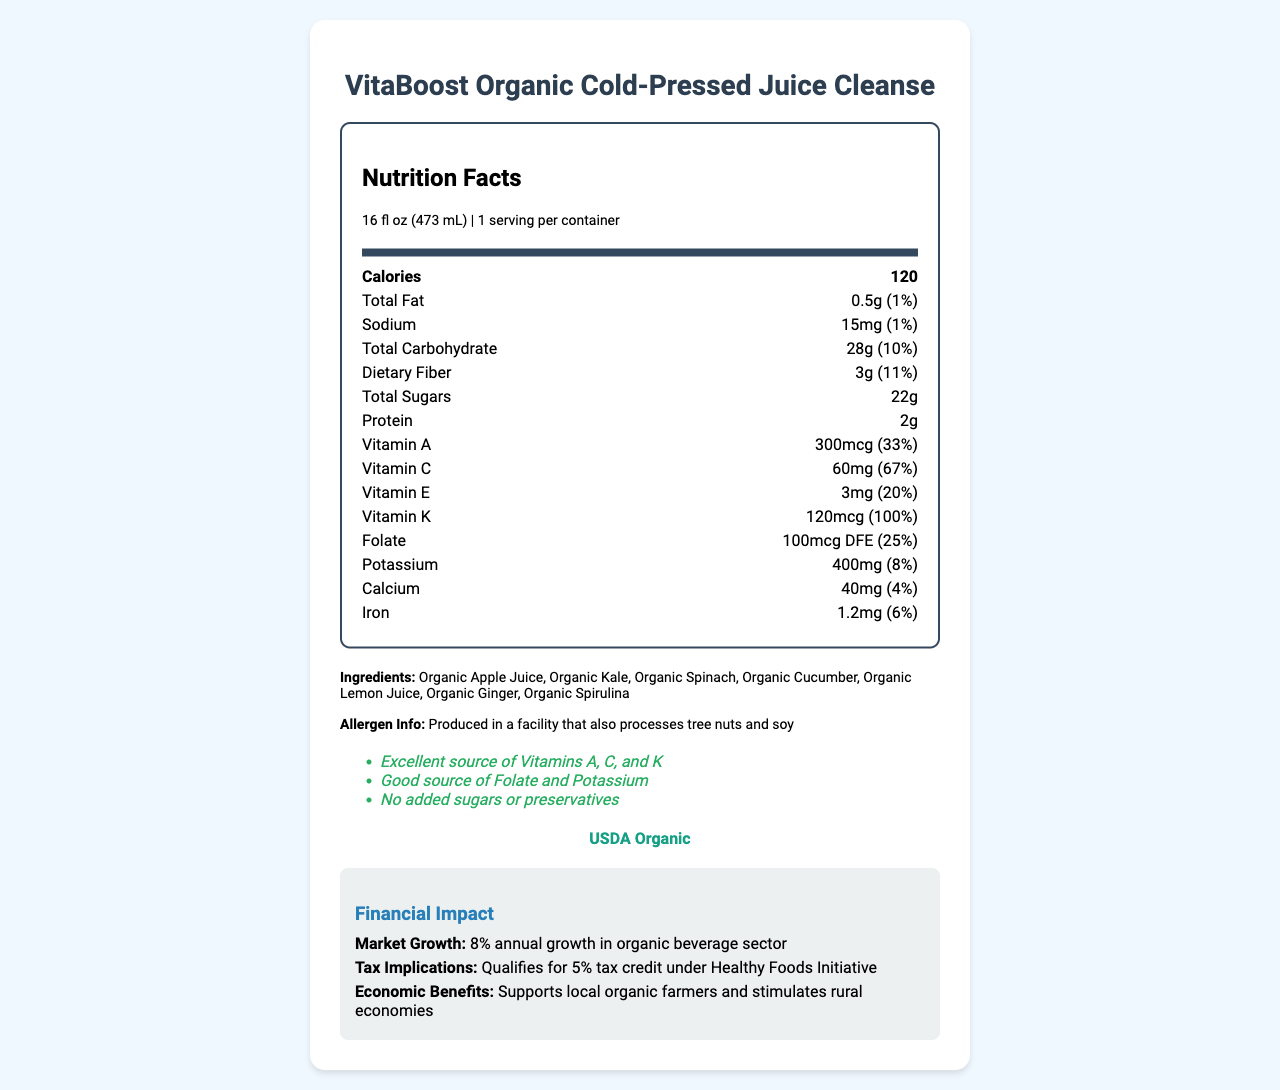What is the serving size of VitaBoost Organic Cold-Pressed Juice Cleanse? The serving size is stated at the top of the Nutrition Facts section as 16 fl oz (473 mL).
Answer: 16 fl oz (473 mL) How many calories are in one serving of the juice? The calories per serving are listed prominently in the Nutrition Facts section as 120.
Answer: 120 What is the amount of dietary fiber per serving? The dietary fiber content is listed in the Nutrition Facts section as 3g.
Answer: 3g Which vitamins are noted as excellent sources in the health claims? The health claims section states that the juice is an excellent source of Vitamins A, C, and K.
Answer: Vitamins A, C, and K What is the daily value percentage of vitamin K per serving? The Nutrition Facts section specifies that the daily value percentage for vitamin K is 100%.
Answer: 100% Which ingredient is listed first on the ingredients list? The first ingredient listed in the ingredients section is Organic Apple Juice.
Answer: Organic Apple Juice Does this product contain added sugars or preservatives? The health claims section states that there are no added sugars or preservatives.
Answer: No How many grams of total sugars are in one serving? The total sugars content is displayed in the Nutrition Facts section as 22g.
Answer: 22g What percentage of the daily value of calcium does one serving provide? The daily value percentage for calcium in one serving is listed as 4% in the Nutrition Facts section.
Answer: 4% What are the tax implications mentioned in the document? The financial impact section mentions that the product qualifies for a 5% tax credit under the Healthy Foods Initiative.
Answer: Qualifies for 5% tax credit under Healthy Foods Initiative What is the certification mentioned for this juice product? The certification section states that the product is USDA Organic.
Answer: USDA Organic What is the annual growth rate in the organic beverage sector mentioned in the document? The financial impact section mentions an 8% annual growth rate in the organic beverage sector.
Answer: 8% Does the product support local organic farmers and stimulate rural economies? The financial impact section highlights the economic benefits that include supporting local organic farmers and stimulating rural economies.
Answer: Yes Is this product FDA approved? The regulatory compliance section states that it meets FDA guidelines for nutrient content claims.
Answer: Yes What is the conclusion about the allergen information provided in the document? The allergen information section indicates that the product is produced in a facility that processes tree nuts and soy.
Answer: Produced in a facility that also processes tree nuts and soy Select the correct ingredient not found in the juice: A. Organic Kale B. Organic Cucumber C. Organic Blueberry The ingredients list includes Organic Kale and Organic Cucumber but not Organic Blueberry.
Answer: C. Organic Blueberry Which of the following statements is true about the juice cleanse? A. It has no Vitamin C B. It contains Vitamin K but no folate C. It contains Vitamin E and has a daily value percentage of 20% The Nutrition Facts section states it has Vitamin E with a daily value percentage of 20%.
Answer: C. It contains Vitamin E and has a daily value percentage of 20% Is the product produced in an allergen-free facility? The allergen section states it is produced in a facility that processes tree nuts and soy, so it is not allergen-free.
Answer: No Summarize the main points of the document. The document provides detailed information about VitaBoost Organic Cold-Pressed Juice Cleanse, including nutritional content, ingredients, health claims, certifications, financial impact, and regulatory compliance. It emphasizes that the product is a rich source of Vitamins A, C, and K, supports local economies, qualifies for a tax credit, and is USDA Organic certified. What are the financial impacts that the document does not cover? The document does not elaborate on broader financial impacts such as international market potential or long-term economic projections.
Answer: Not enough information 